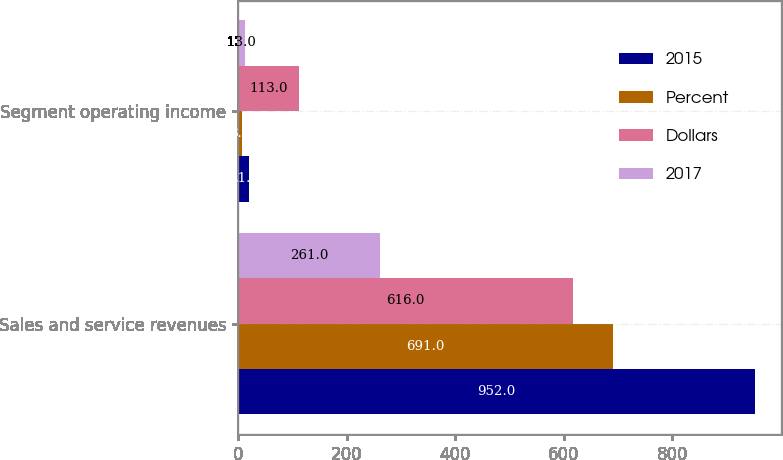Convert chart to OTSL. <chart><loc_0><loc_0><loc_500><loc_500><stacked_bar_chart><ecel><fcel>Sales and service revenues<fcel>Segment operating income<nl><fcel>2015<fcel>952<fcel>21<nl><fcel>Percent<fcel>691<fcel>8<nl><fcel>Dollars<fcel>616<fcel>113<nl><fcel>2017<fcel>261<fcel>13<nl></chart> 